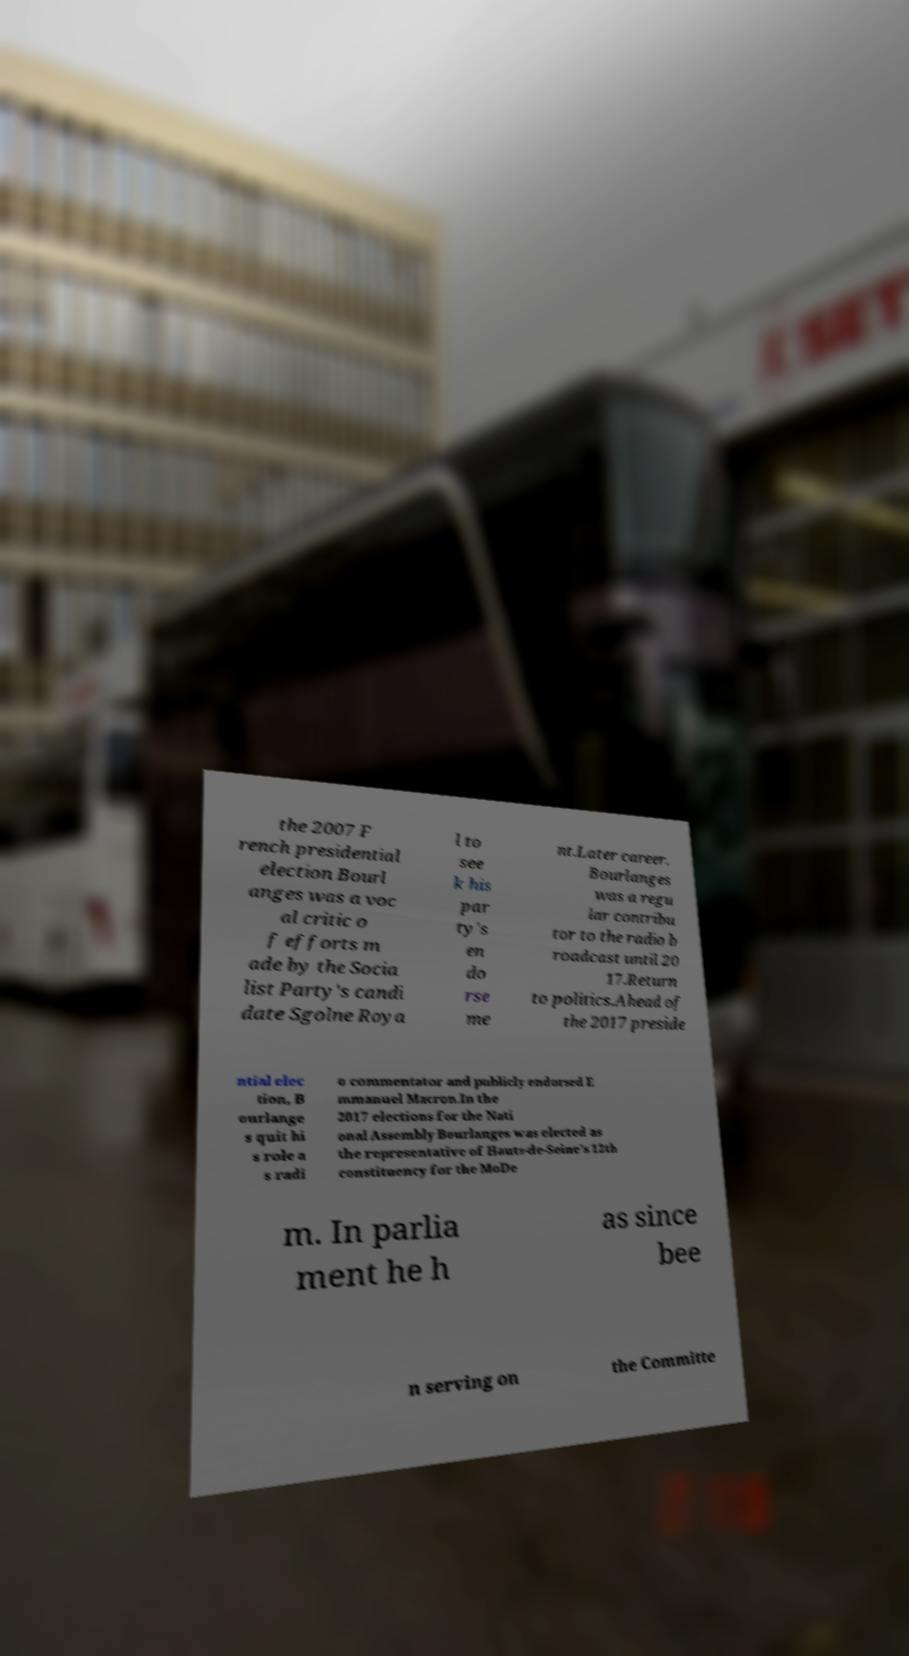Please identify and transcribe the text found in this image. the 2007 F rench presidential election Bourl anges was a voc al critic o f efforts m ade by the Socia list Party's candi date Sgolne Roya l to see k his par ty's en do rse me nt.Later career. Bourlanges was a regu lar contribu tor to the radio b roadcast until 20 17.Return to politics.Ahead of the 2017 preside ntial elec tion, B ourlange s quit hi s role a s radi o commentator and publicly endorsed E mmanuel Macron.In the 2017 elections for the Nati onal Assembly Bourlanges was elected as the representative of Hauts-de-Seine's 12th constituency for the MoDe m. In parlia ment he h as since bee n serving on the Committe 